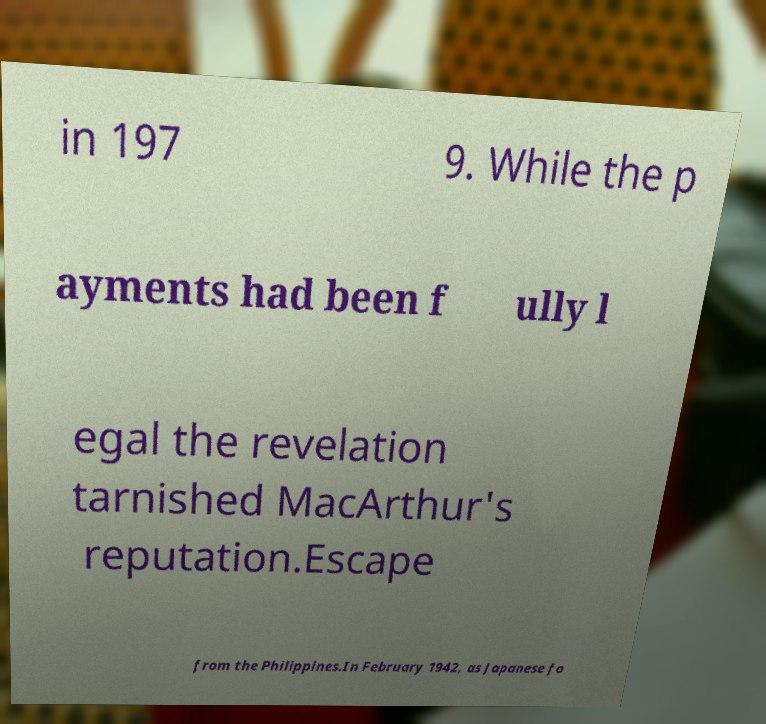What messages or text are displayed in this image? I need them in a readable, typed format. in 197 9. While the p ayments had been f ully l egal the revelation tarnished MacArthur's reputation.Escape from the Philippines.In February 1942, as Japanese fo 